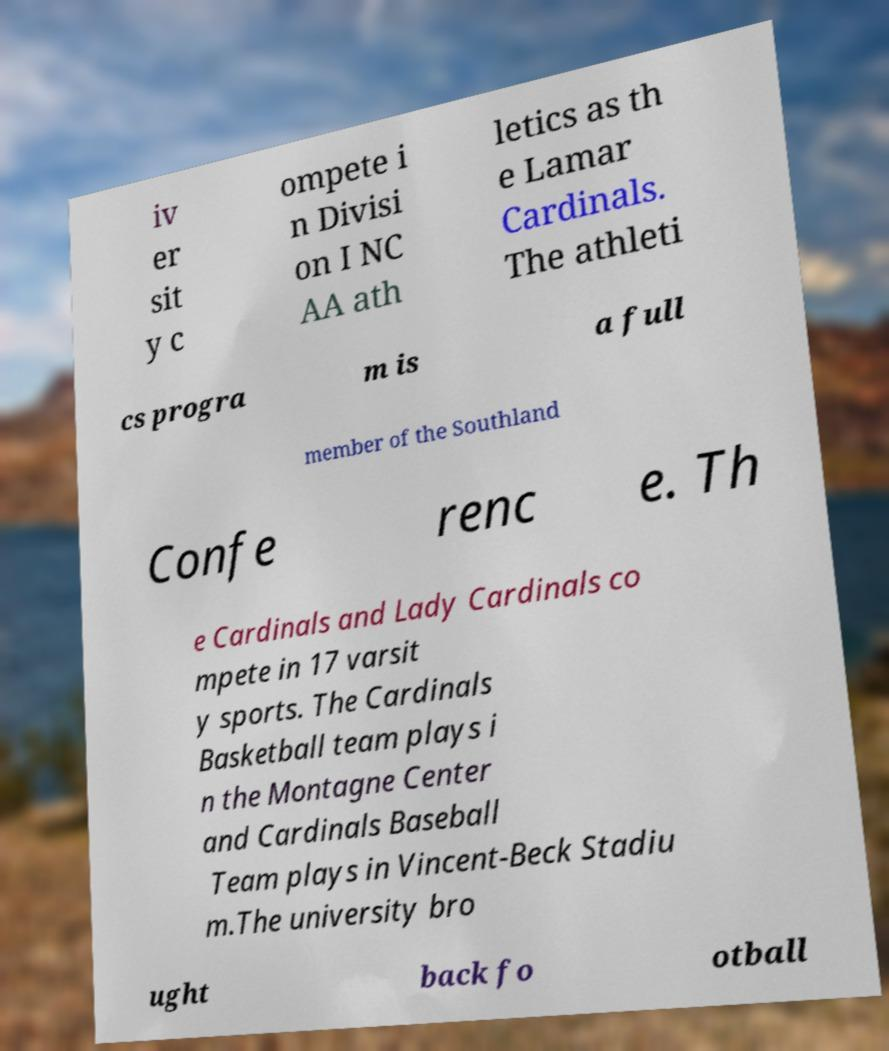I need the written content from this picture converted into text. Can you do that? iv er sit y c ompete i n Divisi on I NC AA ath letics as th e Lamar Cardinals. The athleti cs progra m is a full member of the Southland Confe renc e. Th e Cardinals and Lady Cardinals co mpete in 17 varsit y sports. The Cardinals Basketball team plays i n the Montagne Center and Cardinals Baseball Team plays in Vincent-Beck Stadiu m.The university bro ught back fo otball 